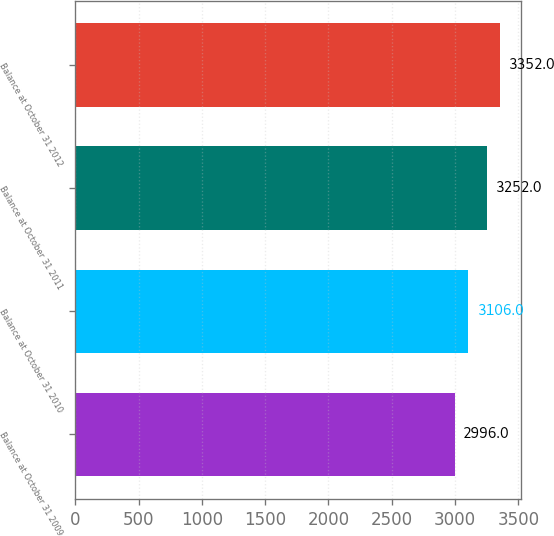<chart> <loc_0><loc_0><loc_500><loc_500><bar_chart><fcel>Balance at October 31 2009<fcel>Balance at October 31 2010<fcel>Balance at October 31 2011<fcel>Balance at October 31 2012<nl><fcel>2996<fcel>3106<fcel>3252<fcel>3352<nl></chart> 